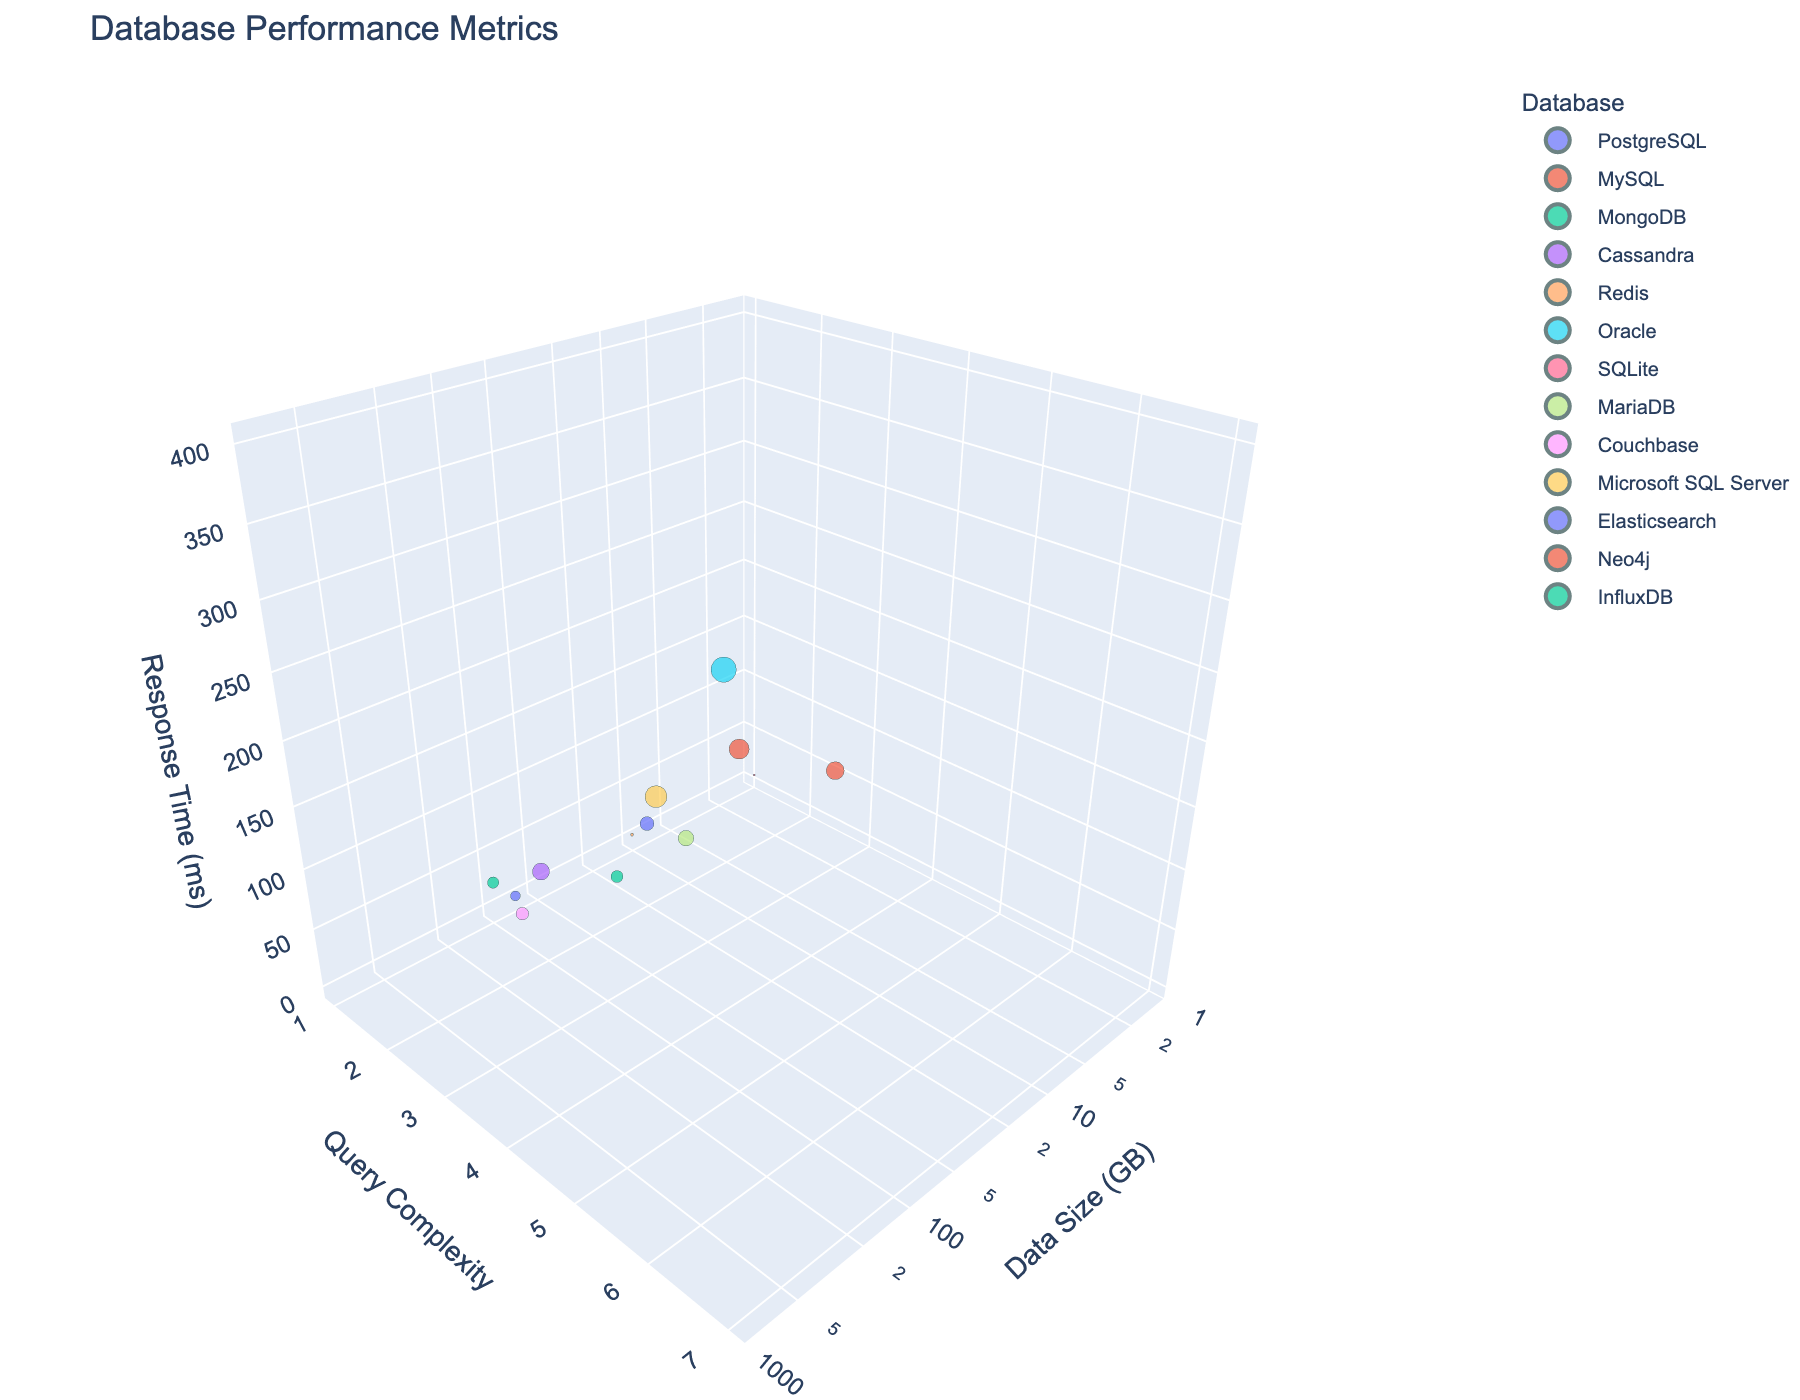What is the largest data point size on the plot? The largest data point size corresponds to the largest response time. Based on the information visible in the figure, the Oracle database has the largest response time of 400 ms.
Answer: Oracle What is the title of the figure? The title is located at the top of the figure. It gives an overview of what the plot represents.
Answer: Database Performance Metrics What database has the smallest response time? The smallest response time can be found by identifying the smallest data point on the z-axis (Response Time in ms). According to the figure, SQLite has the smallest response time of 2 ms.
Answer: SQLite How many data points are displayed in the plot? The number of data points in the plot corresponds to the number of rows in the provided dataset, which is 12.
Answer: 12 How does the Response Time change with increasing Data Size for databases with Query Complexity 2? To determine this, look at the z-axis values (Response Time) for the data points that have a y-axis value (Query Complexity) of 2. For Query Complexity 2, we have MongoDB at 80 ms, and Elasticsearch at 60 ms. As Data Size increases from 150 GB to 200 GB, the Response Time increases from 60 ms to 80 ms.
Answer: Increases Which database has a response time higher than 200 ms and a Query Complexity of 5? To find this, identify the data points where the z-axis value (Response Time) is greater than 200 ms and the y-axis value (Query Complexity) is 5. The plot shows MySQL with a Response Time of 250 ms and Neo4j with a Response Time of 200 ms. Hence, MySQL meets the criteria.
Answer: MySQL Which two databases have similar response times but different data sizes above 50 GB? Identify the data points with similar z-axis values (Response Time) but different x-axis values (Data Size) above 50 GB. MariaDB and Cassandra have similar response times (MariaDB: 150 ms, Cassandra: 180 ms) and different data sizes (MariaDB: 75 GB, Cassandra: 500 GB).
Answer: MariaDB and Cassandra What is the general trend in response time with increasing data size among the databases tested? By observing the overall distribution of data points in the 3D space, particularly along the Data Size (x-axis) and Response Time (z-axis), most databases with larger data sizes show a trend of higher response times.
Answer: Increases Is there any database that has a high Query Complexity (greater than 4) but a Response Time under 200 ms? To answer this, look for data points with y-axis values (Query Complexity) greater than 4 and z-axis values (Response Time) under 200 ms. None of the databases with a Query Complexity greater than 4 have a Response Time under 200 ms.
Answer: No 